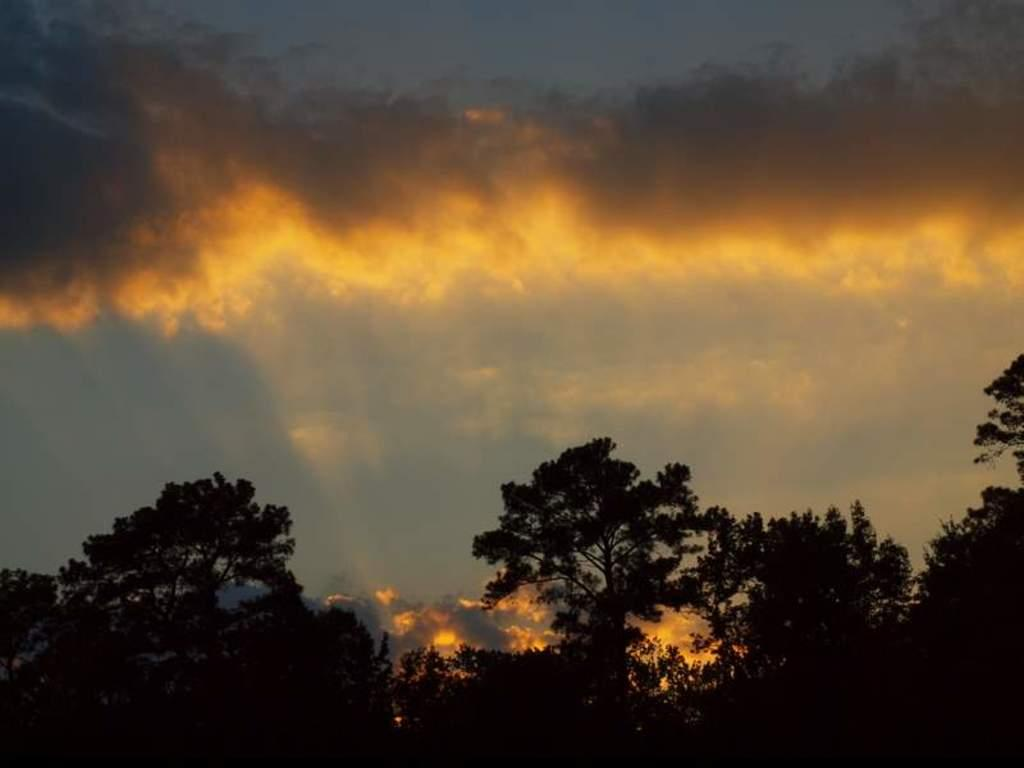What type of vegetation can be seen in the image? There are trees in the image. What is visible in the background of the image? The sky is visible in the image. What colors can be seen in the sky? The sky has blue, black, and orange colors. Can you see a snake slithering along the edge of the trees in the image? There is no snake present in the image, and the edge of the trees is not visible. 